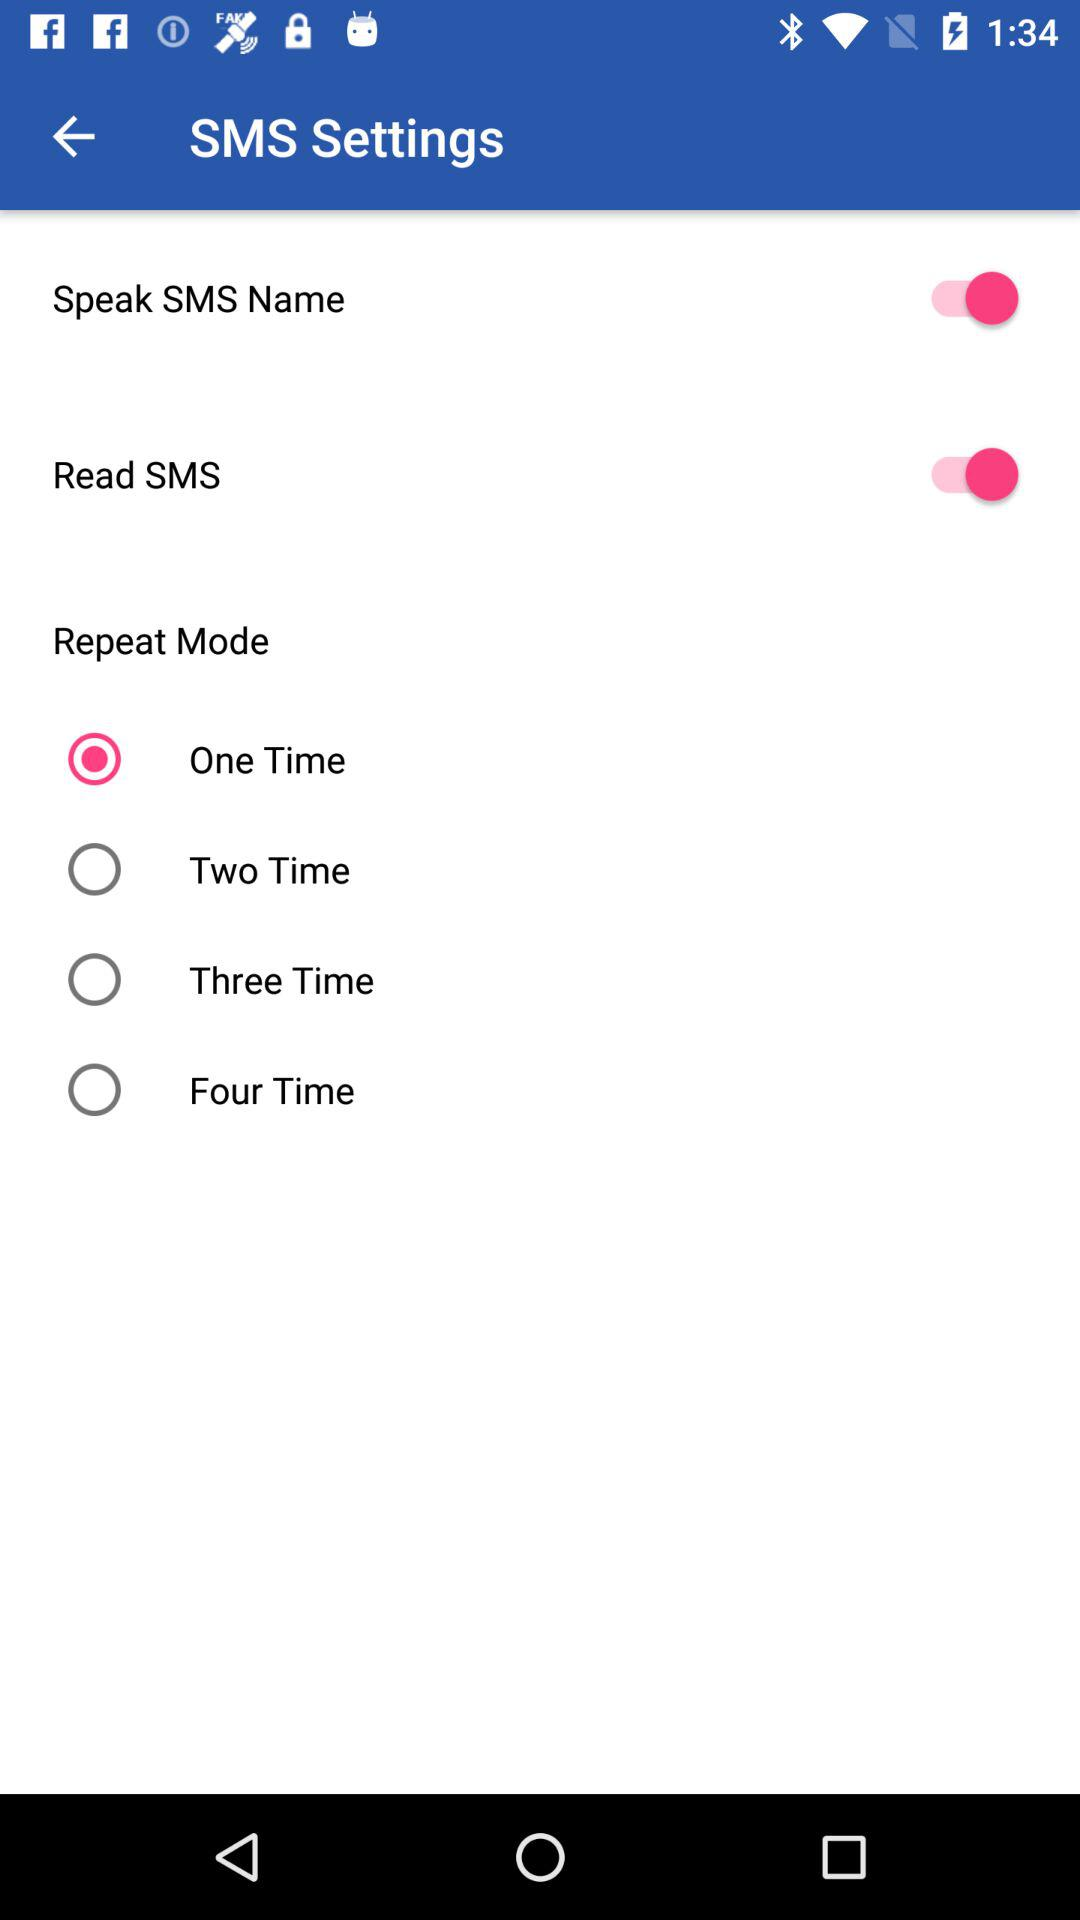What is the status of the "Speak SMS Name"? The status is "on". 